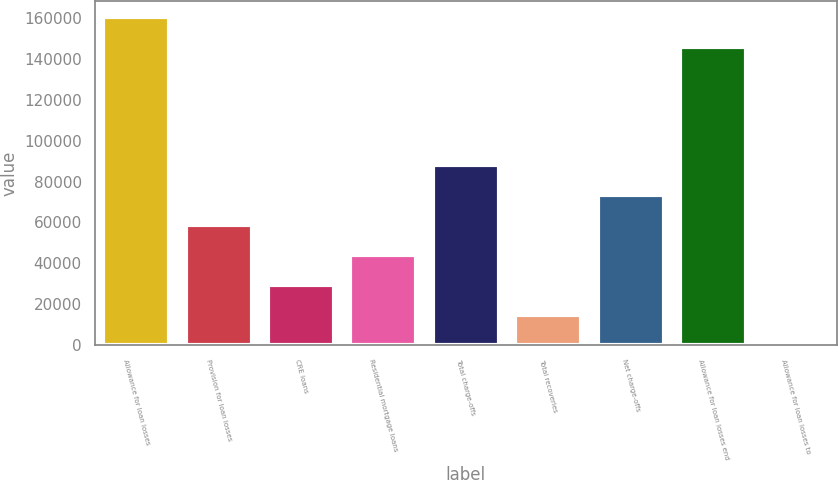Convert chart to OTSL. <chart><loc_0><loc_0><loc_500><loc_500><bar_chart><fcel>Allowance for loan losses<fcel>Provision for loan losses<fcel>CRE loans<fcel>Residential mortgage loans<fcel>Total charge-offs<fcel>Total recoveries<fcel>Net charge-offs<fcel>Allowance for loan losses end<fcel>Allowance for loan losses to<nl><fcel>160452<fcel>58834.9<fcel>29418.5<fcel>44126.7<fcel>88251.3<fcel>14710.4<fcel>73543.1<fcel>145744<fcel>2.18<nl></chart> 